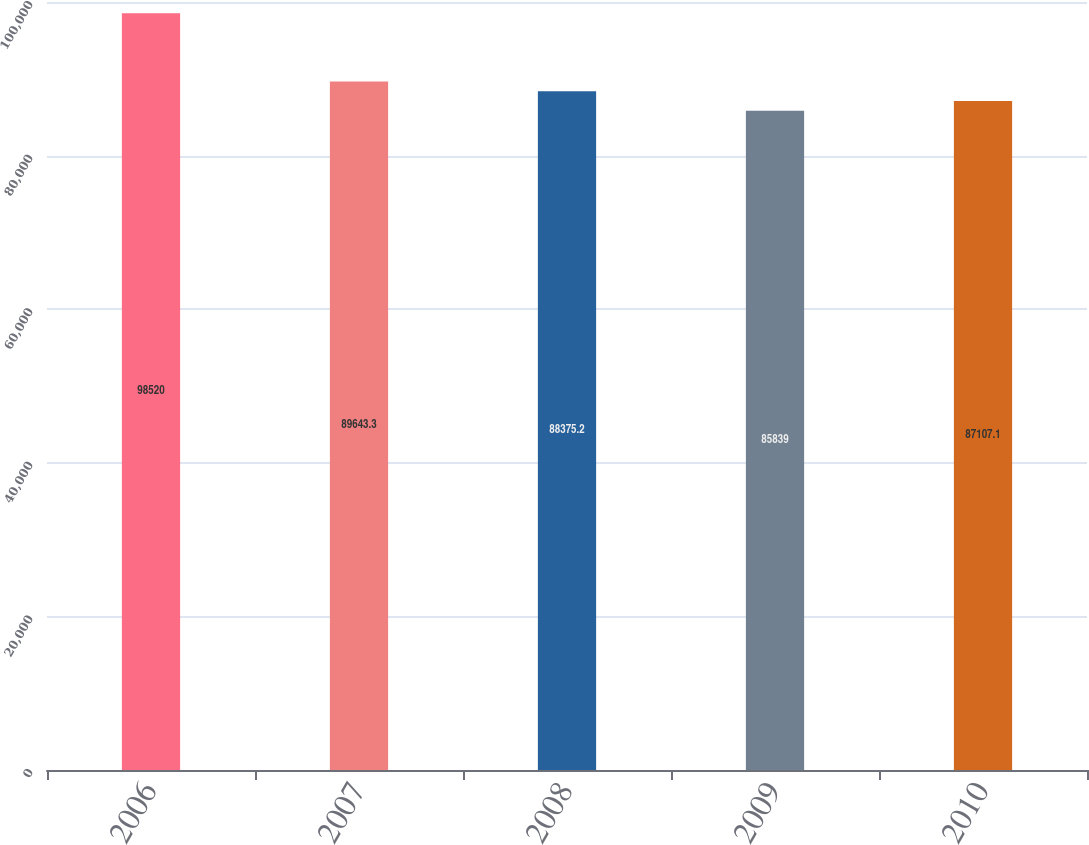Convert chart to OTSL. <chart><loc_0><loc_0><loc_500><loc_500><bar_chart><fcel>2006<fcel>2007<fcel>2008<fcel>2009<fcel>2010<nl><fcel>98520<fcel>89643.3<fcel>88375.2<fcel>85839<fcel>87107.1<nl></chart> 